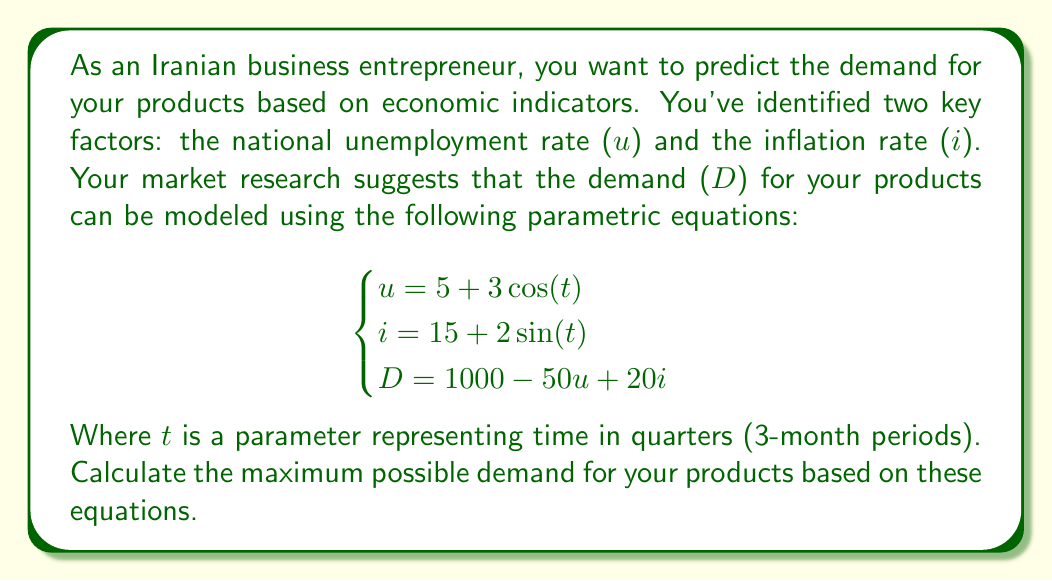Could you help me with this problem? To find the maximum possible demand, we need to follow these steps:

1) First, we need to express D in terms of t:
   $$D = 1000 - 50(5 + 3\cos(t)) + 20(15 + 2\sin(t))$$
   $$D = 1000 - 250 - 150\cos(t) + 300 + 40\sin(t)$$
   $$D = 1050 - 150\cos(t) + 40\sin(t)$$

2) To find the maximum value of D, we need to find where its derivative with respect to t is zero:
   $$\frac{dD}{dt} = 150\sin(t) + 40\cos(t)$$

3) Set this equal to zero:
   $$150\sin(t) + 40\cos(t) = 0$$

4) Divide both sides by $\cos(t)$ (assuming $\cos(t) \neq 0$):
   $$150\tan(t) + 40 = 0$$
   $$\tan(t) = -\frac{40}{150} = -\frac{4}{15}$$

5) Take the arctangent of both sides:
   $$t = \arctan(-\frac{4}{15}) \approx -0.2606 \text{ radians}$$

6) To confirm this is a maximum, we can check the second derivative:
   $$\frac{d^2D}{dt^2} = 150\cos(t) - 40\sin(t)$$
   At $t = -0.2606$, this is negative, confirming a maximum.

7) Now, we can plug this t-value back into our equation for D:
   $$D = 1050 - 150\cos(-0.2606) + 40\sin(-0.2606)$$

8) Calculate this value to get the maximum demand.
Answer: The maximum possible demand is approximately 1194.54 units. 